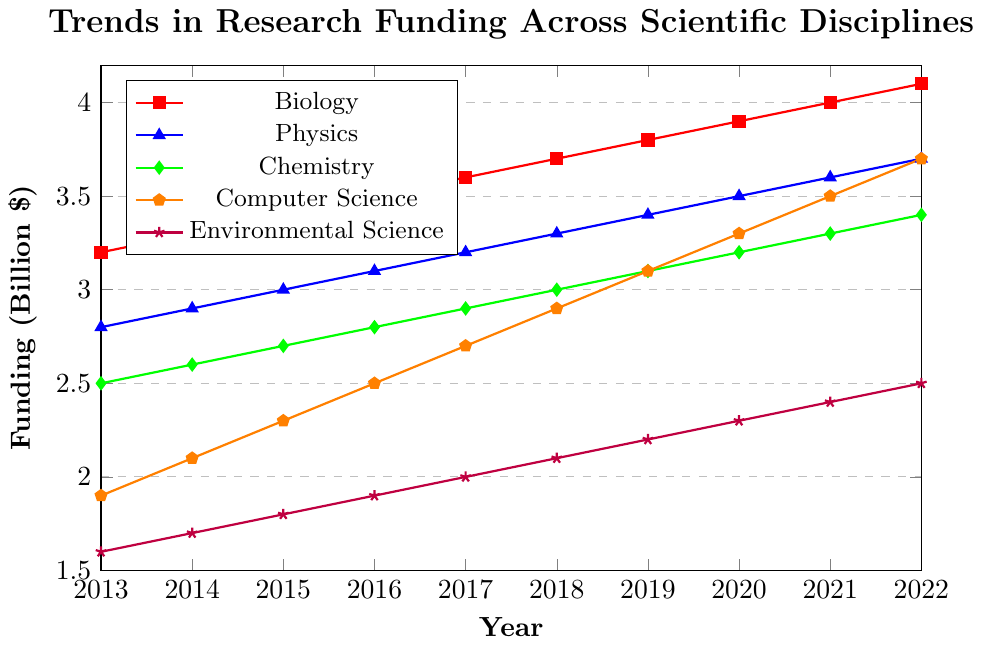What is the trend in funding for Biology from 2013 to 2022? To observe the trend in funding for Biology, we look at the data points from 2013 to 2022 in the figure. The values are consistently increasing from 3.2 billion in 2013 to 4.1 billion in 2022. This indicates a steady upward trend in funding for Biology over the past decade.
Answer: Steady upward trend Compare the funding between Physics and Chemistry in 2016. Which is higher? By examining the data points for 2016, Physics has a funding value of 3.1 billion while Chemistry has a value of 2.8 billion. Thus, Physics has higher funding than Chemistry in 2016.
Answer: Physics Which discipline has the highest increase in funding between 2013 and 2022? To determine this, we calculate the difference between the funding values in 2022 and 2013 for each discipline. Biology: 4.1 - 3.2 = 0.9, Physics: 3.7 - 2.8 = 0.9, Chemistry: 3.4 - 2.5 = 0.9, Computer Science: 3.7 - 1.9 = 1.8, Environmental Science: 2.5 - 1.6 = 0.9. Computer Science shows the highest increase in funding.
Answer: Computer Science What is the average funding for Environmental Science over the decade? Adding the yearly funding values for Environmental Science from 2013 to 2022 and dividing by 10: (1.6 + 1.7 + 1.8 + 1.9 + 2.0 + 2.1 + 2.2 + 2.3 + 2.4 + 2.5) / 10 results in an average funding of 2.05 billion.
Answer: 2.05 billion In what year did Computer Science funding surpass 3 billion? Reviewing the funding values for Computer Science, the year 2019 marks the first time it surpasses 3 billion with a value of 3.1 billion.
Answer: 2019 Identify the discipline with the least funding in 2013. From the 2013 funding data, the values are: Biology (3.2), Physics (2.8), Chemistry (2.5), Computer Science (1.9), Environmental Science (1.6). Environmental Science has the least funding at 1.6 billion.
Answer: Environmental Science How many disciplines had funding over 3 billion in 2020? Examining the funding values for 2020: Biology (3.9), Physics (3.5), Chemistry (3.2), Computer Science (3.3), Environmental Science (2.3). Four disciplines (Biology, Physics, Chemistry, Computer Science) had funding over 3 billion.
Answer: Four disciplines What is the sum of funding for Chemistry and Environmental Science in 2021? Adding the 2021 funding values for Chemistry (3.3 billion) and Environmental Science (2.4 billion): 3.3 + 2.4 = 5.7 billion.
Answer: 5.7 billion 